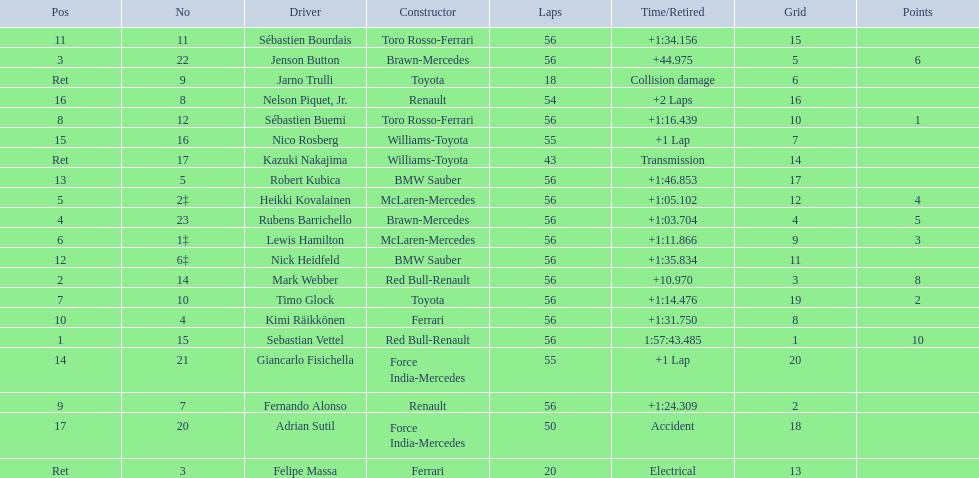Who were all of the drivers in the 2009 chinese grand prix? Sebastian Vettel, Mark Webber, Jenson Button, Rubens Barrichello, Heikki Kovalainen, Lewis Hamilton, Timo Glock, Sébastien Buemi, Fernando Alonso, Kimi Räikkönen, Sébastien Bourdais, Nick Heidfeld, Robert Kubica, Giancarlo Fisichella, Nico Rosberg, Nelson Piquet, Jr., Adrian Sutil, Kazuki Nakajima, Felipe Massa, Jarno Trulli. And what were their finishing times? 1:57:43.485, +10.970, +44.975, +1:03.704, +1:05.102, +1:11.866, +1:14.476, +1:16.439, +1:24.309, +1:31.750, +1:34.156, +1:35.834, +1:46.853, +1 Lap, +1 Lap, +2 Laps, Accident, Transmission, Electrical, Collision damage. Which player faced collision damage and retired from the race? Jarno Trulli. 